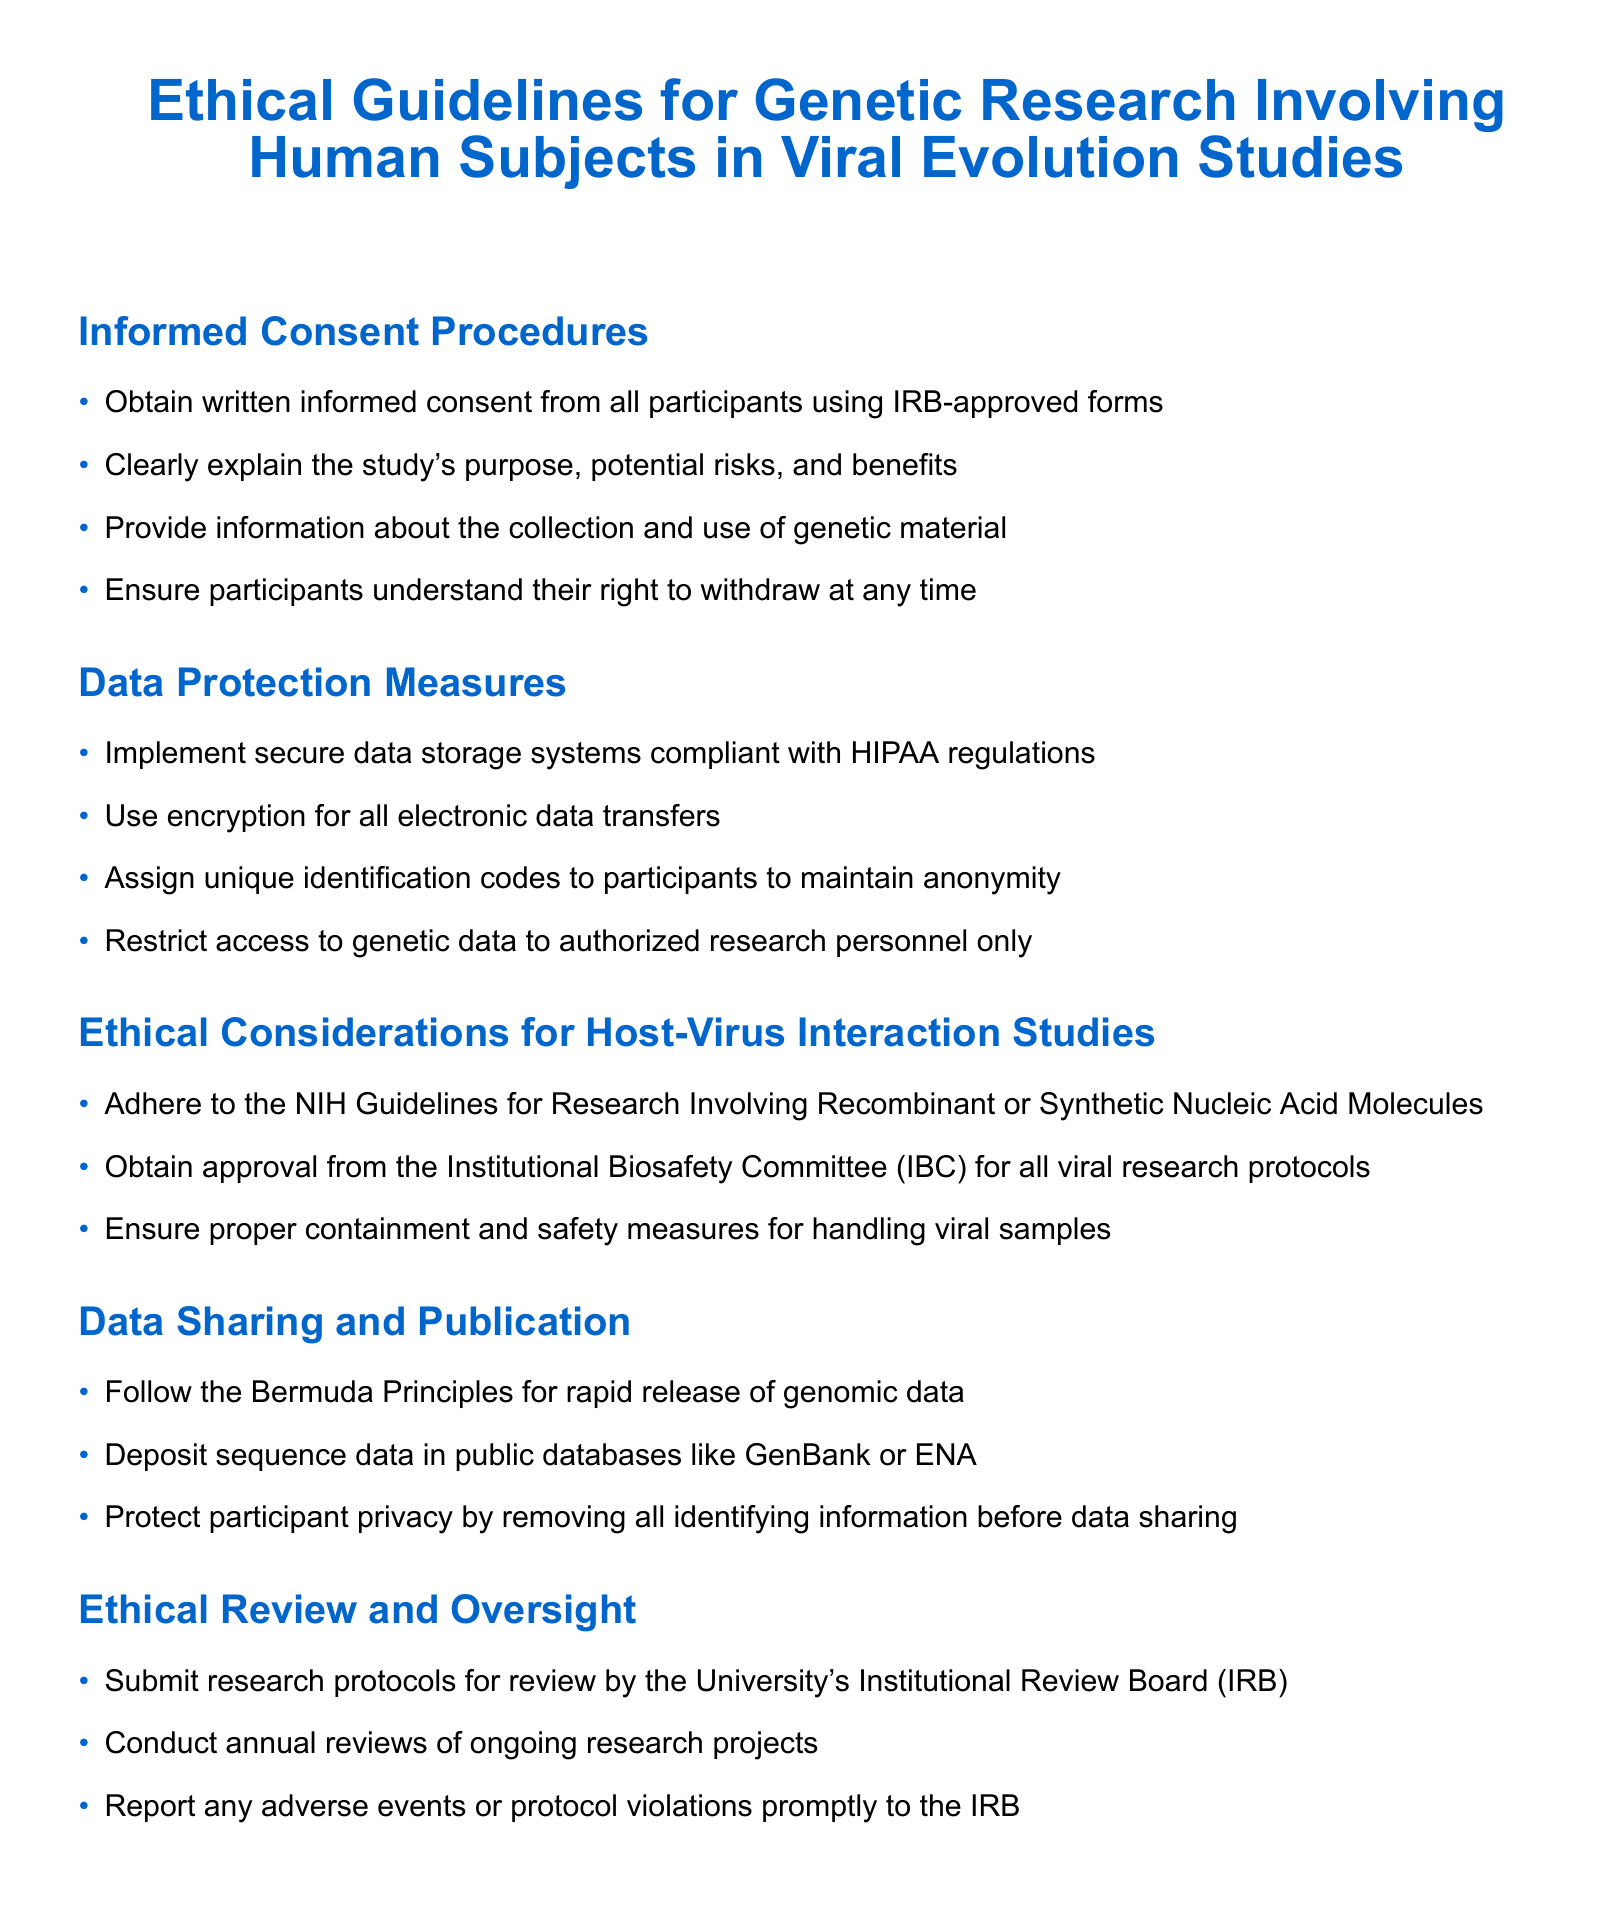What is required from participants according to informed consent procedures? Participants must provide written informed consent using IRB-approved forms.
Answer: Written informed consent What type of data storage systems should researchers implement? Researchers should implement secure data storage systems compliant with HIPAA regulations.
Answer: HIPAA compliant What guidelines must be adhered to for host-virus interaction studies? The NIH Guidelines for Research Involving Recombinant or Synthetic Nucleic Acid Molecules must be adhered to.
Answer: NIH Guidelines How should genetic data be shared according to the document? Genetic data should follow the Bermuda Principles for rapid release of genomic data.
Answer: Bermuda Principles Who reviews research protocols in the ethical review and oversight section? Research protocols are reviewed by the University's Institutional Review Board (IRB).
Answer: Institutional Review Board (IRB) What right do participants have regarding their participation? Participants have the right to withdraw at any time.
Answer: Right to withdraw What must be removed before data sharing? All identifying information must be removed before data sharing.
Answer: Identifying information How often are ongoing research projects reviewed? Ongoing research projects are reviewed annually.
Answer: Annually 